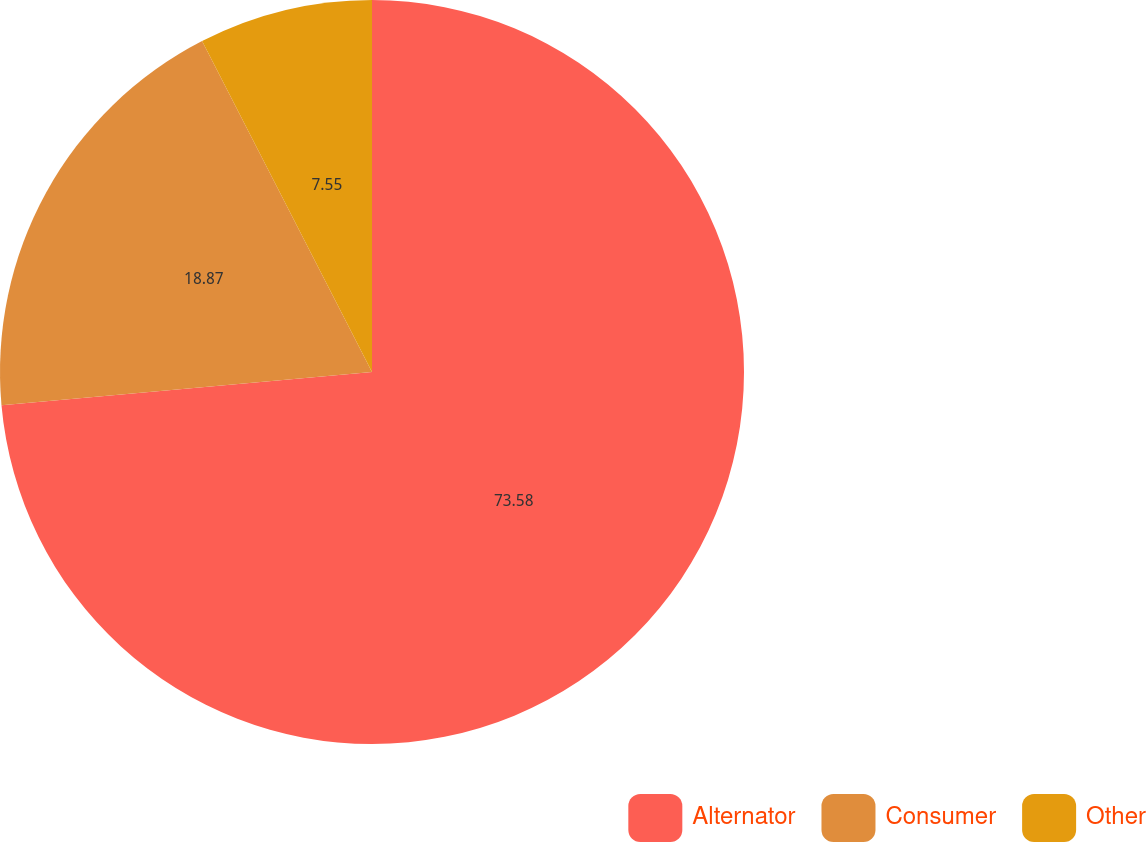<chart> <loc_0><loc_0><loc_500><loc_500><pie_chart><fcel>Alternator<fcel>Consumer<fcel>Other<nl><fcel>73.58%<fcel>18.87%<fcel>7.55%<nl></chart> 